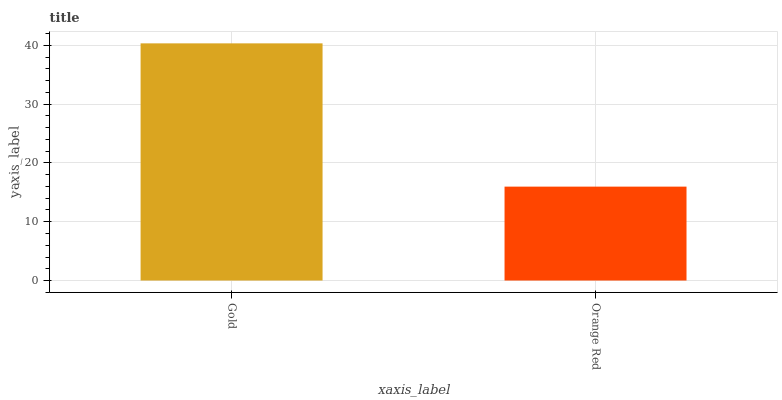Is Orange Red the minimum?
Answer yes or no. Yes. Is Gold the maximum?
Answer yes or no. Yes. Is Orange Red the maximum?
Answer yes or no. No. Is Gold greater than Orange Red?
Answer yes or no. Yes. Is Orange Red less than Gold?
Answer yes or no. Yes. Is Orange Red greater than Gold?
Answer yes or no. No. Is Gold less than Orange Red?
Answer yes or no. No. Is Gold the high median?
Answer yes or no. Yes. Is Orange Red the low median?
Answer yes or no. Yes. Is Orange Red the high median?
Answer yes or no. No. Is Gold the low median?
Answer yes or no. No. 